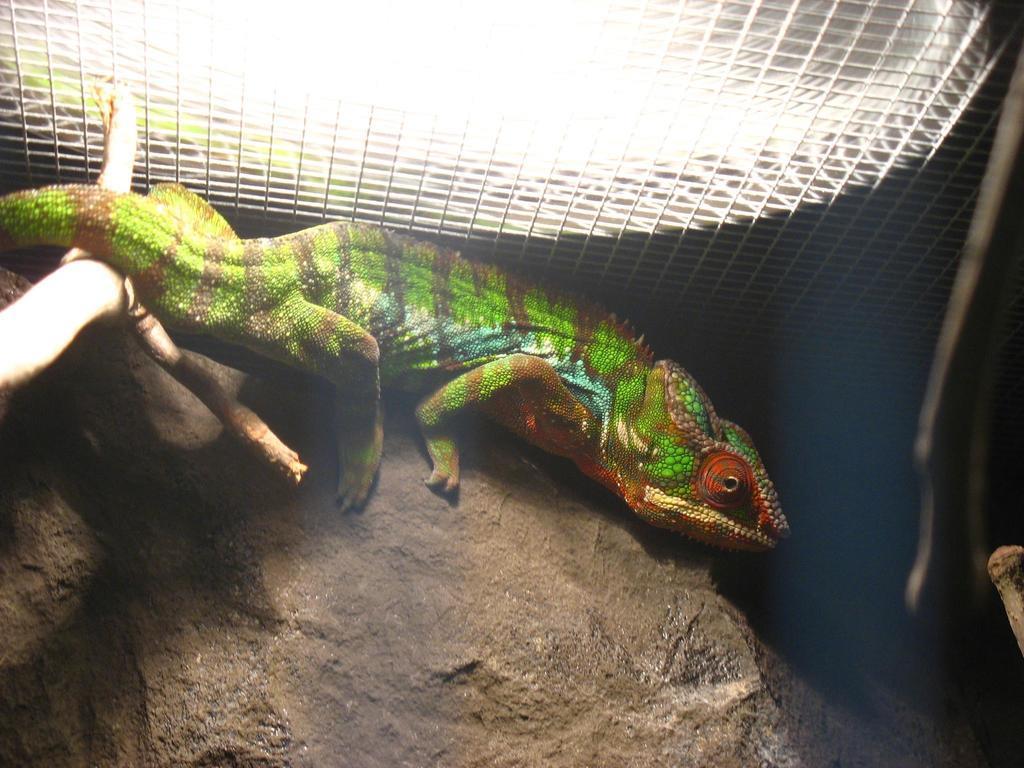Can you describe this image briefly? In this picture we can see a reptile in the middle, at the bottom there is a rock, we can see net at the top of the picture. 